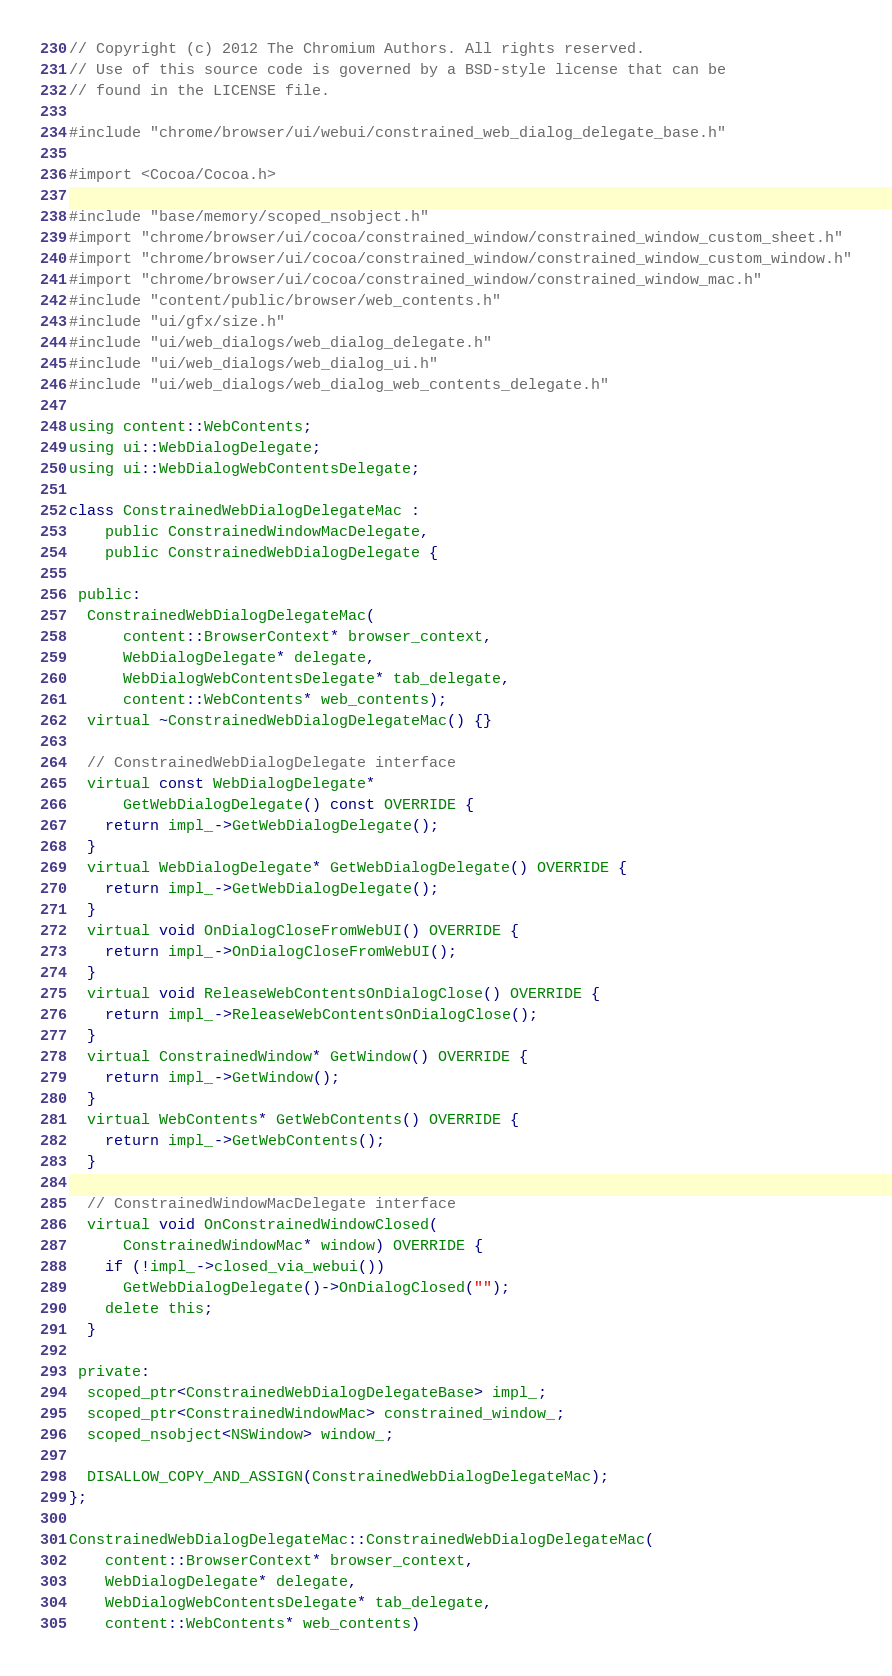Convert code to text. <code><loc_0><loc_0><loc_500><loc_500><_ObjectiveC_>// Copyright (c) 2012 The Chromium Authors. All rights reserved.
// Use of this source code is governed by a BSD-style license that can be
// found in the LICENSE file.

#include "chrome/browser/ui/webui/constrained_web_dialog_delegate_base.h"

#import <Cocoa/Cocoa.h>

#include "base/memory/scoped_nsobject.h"
#import "chrome/browser/ui/cocoa/constrained_window/constrained_window_custom_sheet.h"
#import "chrome/browser/ui/cocoa/constrained_window/constrained_window_custom_window.h"
#import "chrome/browser/ui/cocoa/constrained_window/constrained_window_mac.h"
#include "content/public/browser/web_contents.h"
#include "ui/gfx/size.h"
#include "ui/web_dialogs/web_dialog_delegate.h"
#include "ui/web_dialogs/web_dialog_ui.h"
#include "ui/web_dialogs/web_dialog_web_contents_delegate.h"

using content::WebContents;
using ui::WebDialogDelegate;
using ui::WebDialogWebContentsDelegate;

class ConstrainedWebDialogDelegateMac :
    public ConstrainedWindowMacDelegate,
    public ConstrainedWebDialogDelegate {

 public:
  ConstrainedWebDialogDelegateMac(
      content::BrowserContext* browser_context,
      WebDialogDelegate* delegate,
      WebDialogWebContentsDelegate* tab_delegate,
      content::WebContents* web_contents);
  virtual ~ConstrainedWebDialogDelegateMac() {}

  // ConstrainedWebDialogDelegate interface
  virtual const WebDialogDelegate*
      GetWebDialogDelegate() const OVERRIDE {
    return impl_->GetWebDialogDelegate();
  }
  virtual WebDialogDelegate* GetWebDialogDelegate() OVERRIDE {
    return impl_->GetWebDialogDelegate();
  }
  virtual void OnDialogCloseFromWebUI() OVERRIDE {
    return impl_->OnDialogCloseFromWebUI();
  }
  virtual void ReleaseWebContentsOnDialogClose() OVERRIDE {
    return impl_->ReleaseWebContentsOnDialogClose();
  }
  virtual ConstrainedWindow* GetWindow() OVERRIDE {
    return impl_->GetWindow();
  }
  virtual WebContents* GetWebContents() OVERRIDE {
    return impl_->GetWebContents();
  }

  // ConstrainedWindowMacDelegate interface
  virtual void OnConstrainedWindowClosed(
      ConstrainedWindowMac* window) OVERRIDE {
    if (!impl_->closed_via_webui())
      GetWebDialogDelegate()->OnDialogClosed("");
    delete this;
  }

 private:
  scoped_ptr<ConstrainedWebDialogDelegateBase> impl_;
  scoped_ptr<ConstrainedWindowMac> constrained_window_;
  scoped_nsobject<NSWindow> window_;

  DISALLOW_COPY_AND_ASSIGN(ConstrainedWebDialogDelegateMac);
};

ConstrainedWebDialogDelegateMac::ConstrainedWebDialogDelegateMac(
    content::BrowserContext* browser_context,
    WebDialogDelegate* delegate,
    WebDialogWebContentsDelegate* tab_delegate,
    content::WebContents* web_contents)</code> 